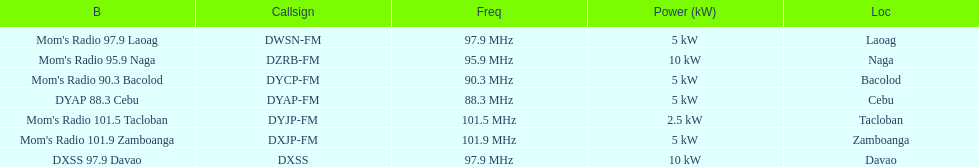What is the number of these stations broadcasting at a frequency of greater than 100 mhz? 2. 